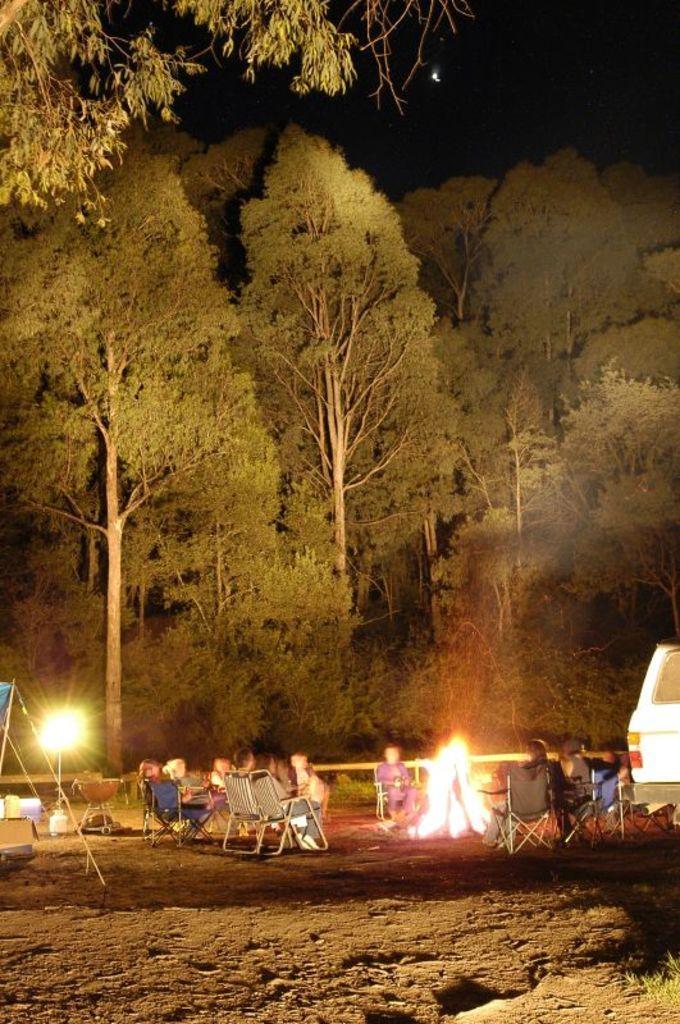Can you describe this image briefly? In this picture we can see a group of people sitting on chairs, fire and a vehicle on the ground and in the background we can see trees. 